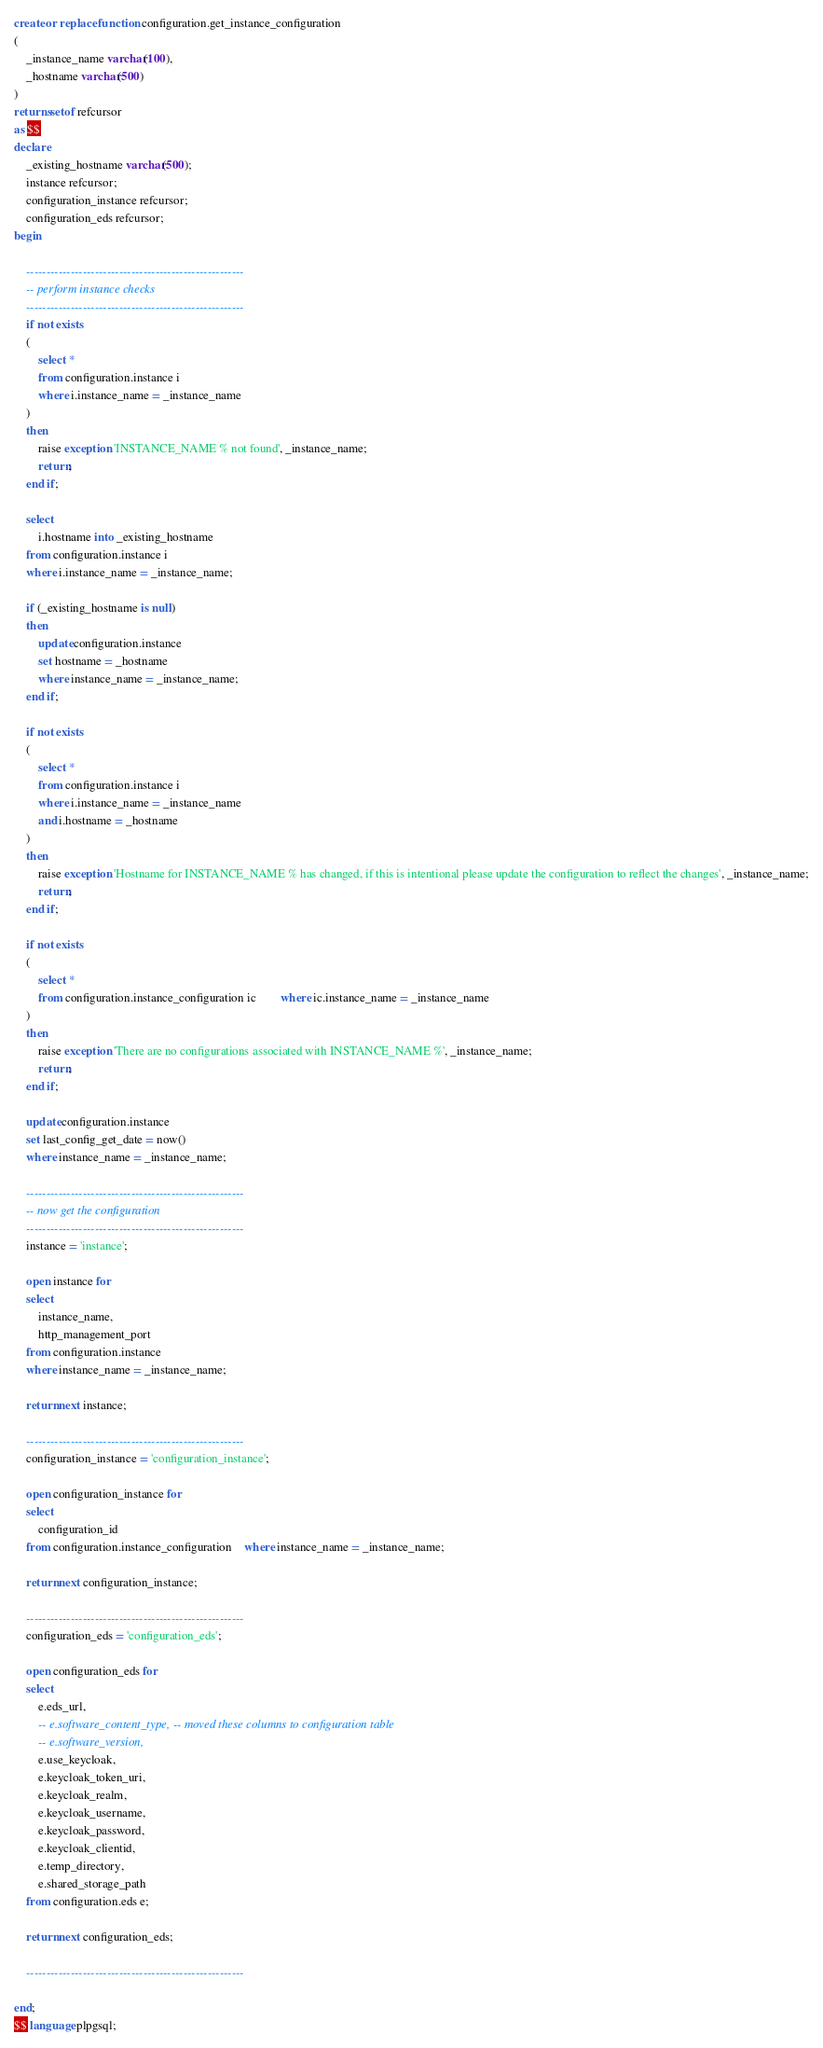Convert code to text. <code><loc_0><loc_0><loc_500><loc_500><_SQL_>
create or replace function configuration.get_instance_configuration
(
	_instance_name varchar(100),
	_hostname varchar(500)
)
returns setof refcursor
as $$
declare
	_existing_hostname varchar(500);
	instance refcursor;
	configuration_instance refcursor;
	configuration_eds refcursor;
begin

	------------------------------------------------------
	-- perform instance checks
	------------------------------------------------------
	if not exists
	(
		select *
		from configuration.instance i
		where i.instance_name = _instance_name
	)
	then
		raise exception 'INSTANCE_NAME % not found', _instance_name;
		return;
	end if;

	select
		i.hostname into _existing_hostname
	from configuration.instance i
	where i.instance_name = _instance_name;

	if (_existing_hostname is null)
	then
		update configuration.instance
		set hostname = _hostname
		where instance_name = _instance_name;
	end if;

	if not exists
	(
		select *
		from configuration.instance i
		where i.instance_name = _instance_name
		and i.hostname = _hostname
	)
	then
		raise exception 'Hostname for INSTANCE_NAME % has changed, if this is intentional please update the configuration to reflect the changes', _instance_name;
		return;
	end if;

	if not exists
	(
		select *
		from configuration.instance_configuration ic		where ic.instance_name = _instance_name
	)
	then
		raise exception 'There are no configurations associated with INSTANCE_NAME %', _instance_name;
		return;
	end if;

	update configuration.instance
	set last_config_get_date = now()
	where instance_name = _instance_name;

	------------------------------------------------------
	-- now get the configuration
	------------------------------------------------------
	instance = 'instance';

	open instance for
	select
		instance_name,
		http_management_port
	from configuration.instance
	where instance_name = _instance_name;

	return next instance;

	------------------------------------------------------
	configuration_instance = 'configuration_instance';

	open configuration_instance for
	select
		configuration_id
	from configuration.instance_configuration	where instance_name = _instance_name;

	return next configuration_instance;

	------------------------------------------------------
	configuration_eds = 'configuration_eds';

	open configuration_eds for
	select
		e.eds_url,
		-- e.software_content_type, -- moved these columns to configuration table
		-- e.software_version,
		e.use_keycloak,
		e.keycloak_token_uri,
		e.keycloak_realm,
		e.keycloak_username,
		e.keycloak_password,
		e.keycloak_clientid,
		e.temp_directory,
		e.shared_storage_path
	from configuration.eds e;

	return next configuration_eds;
	
	------------------------------------------------------
		
end;
$$ language plpgsql;
</code> 